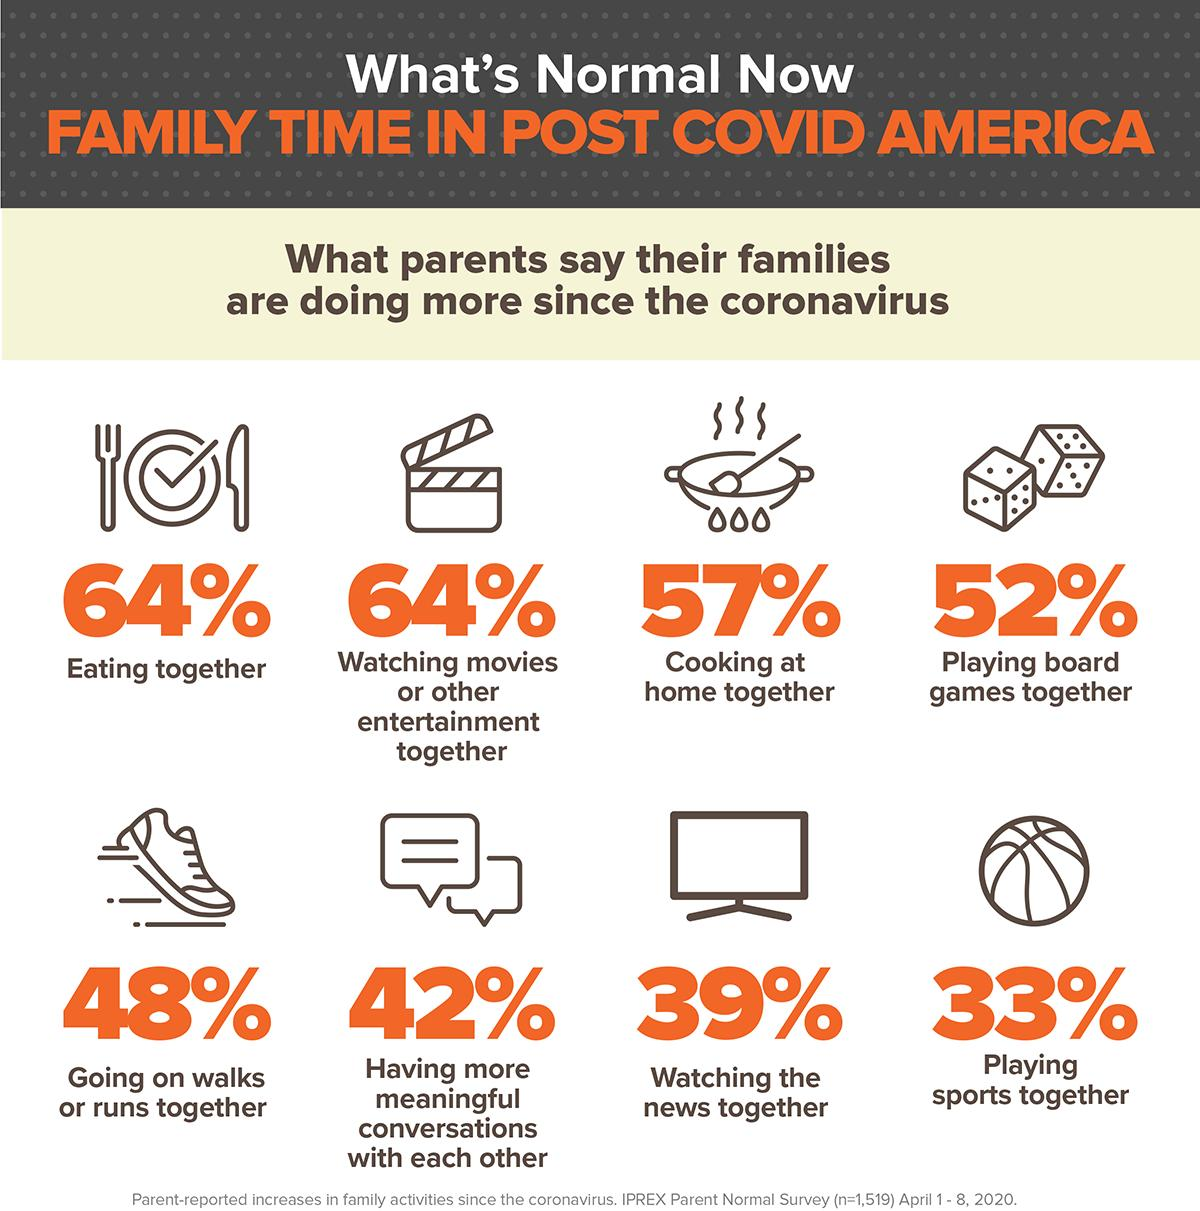Identify some key points in this picture. According to a recent survey, 48% of Americans are interested in jogging since the outbreak of the coronavirus. According to a survey, 64% of Americans report that they regularly enjoy meals with their families. Since the COVID-19 pandemic, a significant percentage of Americans have been opting to watch films at home instead of going to the cinema. According to recent data, approximately 64% of Americans are choosing to watch films at home. This shift in viewing habits reflects the changing preferences of audiences and the impact of the pandemic on the entertainment industry. As the world adapts to the new normal, it will be interesting to see how this trend continues to evolve. According to a recent survey, 39% of Americans express interest in watching the latest updates. According to recent surveys, a substantial 57% of Americans are now preparing their food by themselves due to the ongoing COVID-19 pandemic. 